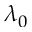Convert formula to latex. <formula><loc_0><loc_0><loc_500><loc_500>\lambda _ { 0 }</formula> 